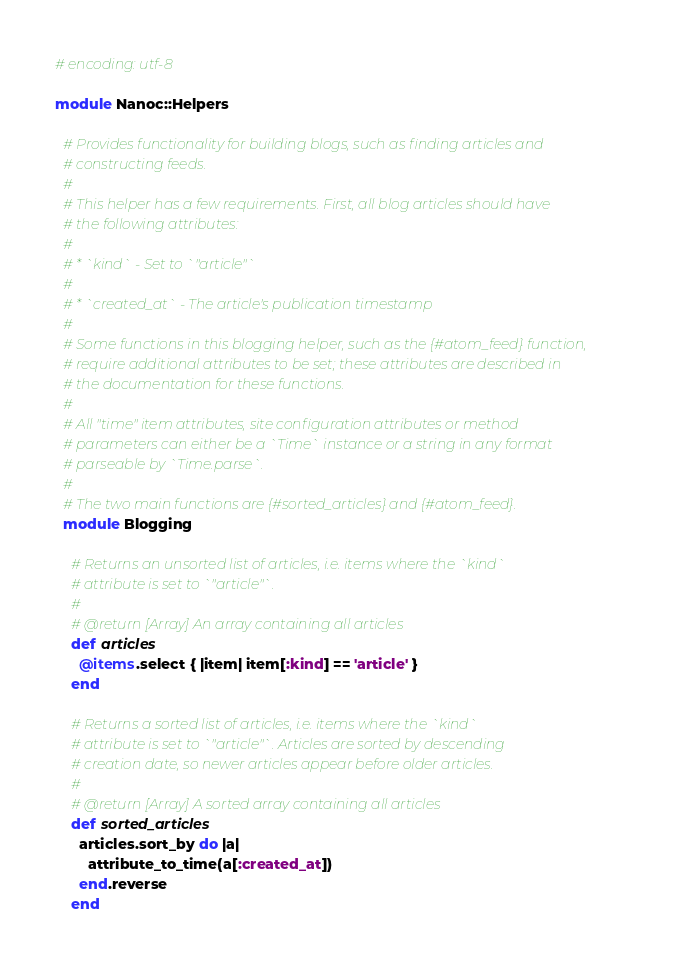Convert code to text. <code><loc_0><loc_0><loc_500><loc_500><_Ruby_># encoding: utf-8

module Nanoc::Helpers

  # Provides functionality for building blogs, such as finding articles and
  # constructing feeds.
  #
  # This helper has a few requirements. First, all blog articles should have
  # the following attributes:
  #
  # * `kind` - Set to `"article"`
  #
  # * `created_at` - The article's publication timestamp
  #
  # Some functions in this blogging helper, such as the {#atom_feed} function,
  # require additional attributes to be set; these attributes are described in
  # the documentation for these functions.
  #
  # All "time" item attributes, site configuration attributes or method
  # parameters can either be a `Time` instance or a string in any format
  # parseable by `Time.parse`.
  #
  # The two main functions are {#sorted_articles} and {#atom_feed}.
  module Blogging

    # Returns an unsorted list of articles, i.e. items where the `kind`
    # attribute is set to `"article"`.
    #
    # @return [Array] An array containing all articles
    def articles
      @items.select { |item| item[:kind] == 'article' }
    end

    # Returns a sorted list of articles, i.e. items where the `kind`
    # attribute is set to `"article"`. Articles are sorted by descending
    # creation date, so newer articles appear before older articles.
    #
    # @return [Array] A sorted array containing all articles
    def sorted_articles
      articles.sort_by do |a|
        attribute_to_time(a[:created_at])
      end.reverse
    end
</code> 